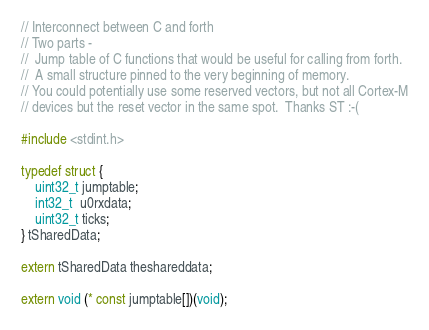Convert code to text. <code><loc_0><loc_0><loc_500><loc_500><_C_>// Interconnect between C and forth 
// Two parts -
//  Jump table of C functions that would be useful for calling from forth.
//  A small structure pinned to the very beginning of memory. 
// You could potentially use some reserved vectors, but not all Cortex-M
// devices but the reset vector in the same spot.  Thanks ST :-(

#include <stdint.h>

typedef struct {
	uint32_t jumptable;
	int32_t  u0rxdata;
	uint32_t ticks;
} tSharedData;

extern tSharedData theshareddata;

extern void (* const jumptable[])(void);

</code> 